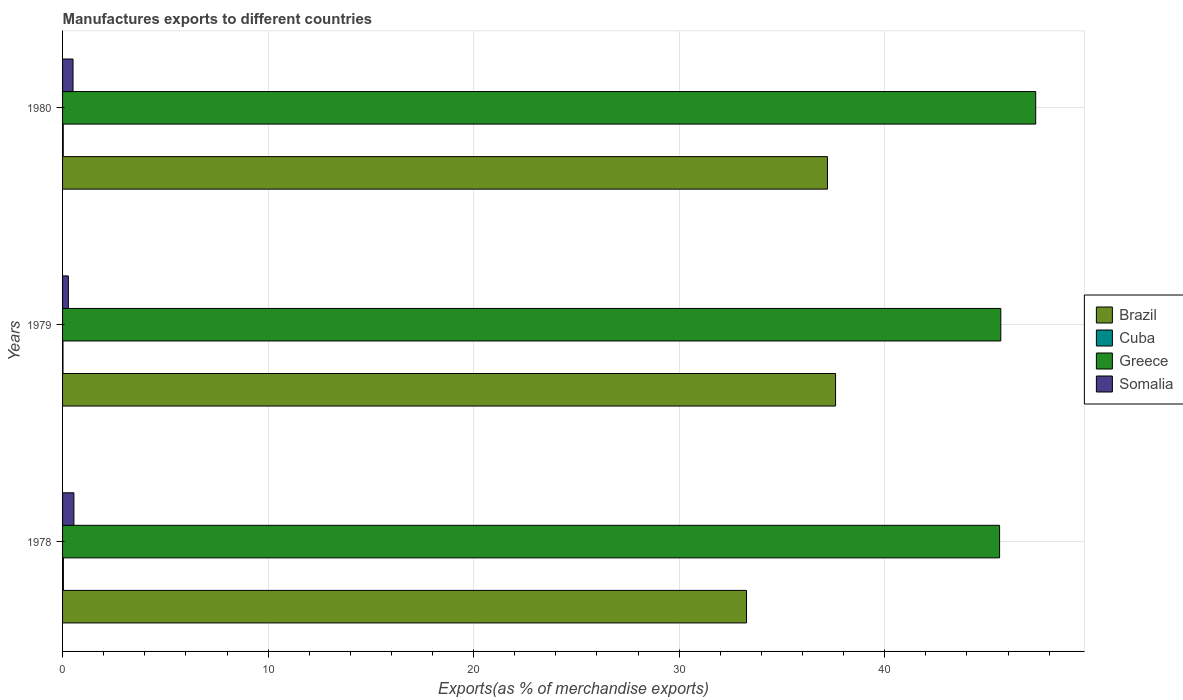How many different coloured bars are there?
Your answer should be compact. 4. Are the number of bars per tick equal to the number of legend labels?
Make the answer very short. Yes. How many bars are there on the 2nd tick from the top?
Offer a very short reply. 4. What is the label of the 1st group of bars from the top?
Give a very brief answer. 1980. In how many cases, is the number of bars for a given year not equal to the number of legend labels?
Keep it short and to the point. 0. What is the percentage of exports to different countries in Somalia in 1979?
Give a very brief answer. 0.28. Across all years, what is the maximum percentage of exports to different countries in Greece?
Provide a succinct answer. 47.35. Across all years, what is the minimum percentage of exports to different countries in Somalia?
Give a very brief answer. 0.28. In which year was the percentage of exports to different countries in Brazil maximum?
Provide a succinct answer. 1979. In which year was the percentage of exports to different countries in Cuba minimum?
Make the answer very short. 1979. What is the total percentage of exports to different countries in Cuba in the graph?
Give a very brief answer. 0.09. What is the difference between the percentage of exports to different countries in Somalia in 1979 and that in 1980?
Your answer should be compact. -0.23. What is the difference between the percentage of exports to different countries in Greece in 1980 and the percentage of exports to different countries in Brazil in 1978?
Your answer should be compact. 14.07. What is the average percentage of exports to different countries in Somalia per year?
Make the answer very short. 0.45. In the year 1978, what is the difference between the percentage of exports to different countries in Somalia and percentage of exports to different countries in Greece?
Make the answer very short. -45.04. In how many years, is the percentage of exports to different countries in Somalia greater than 12 %?
Make the answer very short. 0. What is the ratio of the percentage of exports to different countries in Somalia in 1979 to that in 1980?
Your answer should be compact. 0.56. Is the percentage of exports to different countries in Brazil in 1979 less than that in 1980?
Offer a terse response. No. Is the difference between the percentage of exports to different countries in Somalia in 1979 and 1980 greater than the difference between the percentage of exports to different countries in Greece in 1979 and 1980?
Give a very brief answer. Yes. What is the difference between the highest and the second highest percentage of exports to different countries in Brazil?
Make the answer very short. 0.4. What is the difference between the highest and the lowest percentage of exports to different countries in Greece?
Provide a short and direct response. 1.76. In how many years, is the percentage of exports to different countries in Brazil greater than the average percentage of exports to different countries in Brazil taken over all years?
Provide a succinct answer. 2. Is it the case that in every year, the sum of the percentage of exports to different countries in Somalia and percentage of exports to different countries in Cuba is greater than the sum of percentage of exports to different countries in Brazil and percentage of exports to different countries in Greece?
Give a very brief answer. No. What does the 1st bar from the top in 1978 represents?
Your answer should be very brief. Somalia. What does the 1st bar from the bottom in 1978 represents?
Your answer should be very brief. Brazil. How many bars are there?
Offer a very short reply. 12. What is the difference between two consecutive major ticks on the X-axis?
Ensure brevity in your answer.  10. Does the graph contain any zero values?
Ensure brevity in your answer.  No. Does the graph contain grids?
Provide a succinct answer. Yes. Where does the legend appear in the graph?
Your answer should be compact. Center right. How many legend labels are there?
Keep it short and to the point. 4. How are the legend labels stacked?
Your response must be concise. Vertical. What is the title of the graph?
Offer a very short reply. Manufactures exports to different countries. Does "Kenya" appear as one of the legend labels in the graph?
Keep it short and to the point. No. What is the label or title of the X-axis?
Your answer should be very brief. Exports(as % of merchandise exports). What is the label or title of the Y-axis?
Your response must be concise. Years. What is the Exports(as % of merchandise exports) of Brazil in 1978?
Make the answer very short. 33.28. What is the Exports(as % of merchandise exports) in Cuba in 1978?
Ensure brevity in your answer.  0.04. What is the Exports(as % of merchandise exports) in Greece in 1978?
Your response must be concise. 45.59. What is the Exports(as % of merchandise exports) in Somalia in 1978?
Your answer should be very brief. 0.55. What is the Exports(as % of merchandise exports) of Brazil in 1979?
Give a very brief answer. 37.61. What is the Exports(as % of merchandise exports) of Cuba in 1979?
Keep it short and to the point. 0.02. What is the Exports(as % of merchandise exports) of Greece in 1979?
Keep it short and to the point. 45.65. What is the Exports(as % of merchandise exports) of Somalia in 1979?
Give a very brief answer. 0.28. What is the Exports(as % of merchandise exports) of Brazil in 1980?
Give a very brief answer. 37.21. What is the Exports(as % of merchandise exports) of Cuba in 1980?
Provide a succinct answer. 0.03. What is the Exports(as % of merchandise exports) in Greece in 1980?
Make the answer very short. 47.35. What is the Exports(as % of merchandise exports) of Somalia in 1980?
Offer a very short reply. 0.51. Across all years, what is the maximum Exports(as % of merchandise exports) in Brazil?
Provide a short and direct response. 37.61. Across all years, what is the maximum Exports(as % of merchandise exports) in Cuba?
Your response must be concise. 0.04. Across all years, what is the maximum Exports(as % of merchandise exports) of Greece?
Provide a short and direct response. 47.35. Across all years, what is the maximum Exports(as % of merchandise exports) of Somalia?
Make the answer very short. 0.55. Across all years, what is the minimum Exports(as % of merchandise exports) in Brazil?
Your answer should be compact. 33.28. Across all years, what is the minimum Exports(as % of merchandise exports) of Cuba?
Provide a succinct answer. 0.02. Across all years, what is the minimum Exports(as % of merchandise exports) of Greece?
Give a very brief answer. 45.59. Across all years, what is the minimum Exports(as % of merchandise exports) in Somalia?
Your answer should be very brief. 0.28. What is the total Exports(as % of merchandise exports) of Brazil in the graph?
Keep it short and to the point. 108.1. What is the total Exports(as % of merchandise exports) of Cuba in the graph?
Your answer should be very brief. 0.09. What is the total Exports(as % of merchandise exports) in Greece in the graph?
Make the answer very short. 138.58. What is the total Exports(as % of merchandise exports) in Somalia in the graph?
Make the answer very short. 1.34. What is the difference between the Exports(as % of merchandise exports) in Brazil in 1978 and that in 1979?
Your answer should be compact. -4.33. What is the difference between the Exports(as % of merchandise exports) of Cuba in 1978 and that in 1979?
Ensure brevity in your answer.  0.02. What is the difference between the Exports(as % of merchandise exports) in Greece in 1978 and that in 1979?
Your answer should be compact. -0.06. What is the difference between the Exports(as % of merchandise exports) of Somalia in 1978 and that in 1979?
Your response must be concise. 0.27. What is the difference between the Exports(as % of merchandise exports) of Brazil in 1978 and that in 1980?
Your response must be concise. -3.94. What is the difference between the Exports(as % of merchandise exports) of Cuba in 1978 and that in 1980?
Make the answer very short. 0.01. What is the difference between the Exports(as % of merchandise exports) in Greece in 1978 and that in 1980?
Provide a short and direct response. -1.76. What is the difference between the Exports(as % of merchandise exports) in Somalia in 1978 and that in 1980?
Give a very brief answer. 0.04. What is the difference between the Exports(as % of merchandise exports) of Brazil in 1979 and that in 1980?
Keep it short and to the point. 0.4. What is the difference between the Exports(as % of merchandise exports) in Cuba in 1979 and that in 1980?
Give a very brief answer. -0.01. What is the difference between the Exports(as % of merchandise exports) in Greece in 1979 and that in 1980?
Offer a terse response. -1.7. What is the difference between the Exports(as % of merchandise exports) in Somalia in 1979 and that in 1980?
Provide a succinct answer. -0.23. What is the difference between the Exports(as % of merchandise exports) in Brazil in 1978 and the Exports(as % of merchandise exports) in Cuba in 1979?
Offer a very short reply. 33.26. What is the difference between the Exports(as % of merchandise exports) in Brazil in 1978 and the Exports(as % of merchandise exports) in Greece in 1979?
Ensure brevity in your answer.  -12.37. What is the difference between the Exports(as % of merchandise exports) in Brazil in 1978 and the Exports(as % of merchandise exports) in Somalia in 1979?
Offer a terse response. 32.99. What is the difference between the Exports(as % of merchandise exports) of Cuba in 1978 and the Exports(as % of merchandise exports) of Greece in 1979?
Provide a succinct answer. -45.61. What is the difference between the Exports(as % of merchandise exports) in Cuba in 1978 and the Exports(as % of merchandise exports) in Somalia in 1979?
Keep it short and to the point. -0.24. What is the difference between the Exports(as % of merchandise exports) of Greece in 1978 and the Exports(as % of merchandise exports) of Somalia in 1979?
Make the answer very short. 45.31. What is the difference between the Exports(as % of merchandise exports) in Brazil in 1978 and the Exports(as % of merchandise exports) in Cuba in 1980?
Keep it short and to the point. 33.24. What is the difference between the Exports(as % of merchandise exports) in Brazil in 1978 and the Exports(as % of merchandise exports) in Greece in 1980?
Your answer should be very brief. -14.07. What is the difference between the Exports(as % of merchandise exports) in Brazil in 1978 and the Exports(as % of merchandise exports) in Somalia in 1980?
Your response must be concise. 32.77. What is the difference between the Exports(as % of merchandise exports) of Cuba in 1978 and the Exports(as % of merchandise exports) of Greece in 1980?
Offer a very short reply. -47.31. What is the difference between the Exports(as % of merchandise exports) in Cuba in 1978 and the Exports(as % of merchandise exports) in Somalia in 1980?
Keep it short and to the point. -0.47. What is the difference between the Exports(as % of merchandise exports) in Greece in 1978 and the Exports(as % of merchandise exports) in Somalia in 1980?
Your answer should be compact. 45.08. What is the difference between the Exports(as % of merchandise exports) in Brazil in 1979 and the Exports(as % of merchandise exports) in Cuba in 1980?
Provide a succinct answer. 37.58. What is the difference between the Exports(as % of merchandise exports) in Brazil in 1979 and the Exports(as % of merchandise exports) in Greece in 1980?
Keep it short and to the point. -9.74. What is the difference between the Exports(as % of merchandise exports) of Brazil in 1979 and the Exports(as % of merchandise exports) of Somalia in 1980?
Make the answer very short. 37.1. What is the difference between the Exports(as % of merchandise exports) of Cuba in 1979 and the Exports(as % of merchandise exports) of Greece in 1980?
Give a very brief answer. -47.33. What is the difference between the Exports(as % of merchandise exports) in Cuba in 1979 and the Exports(as % of merchandise exports) in Somalia in 1980?
Your response must be concise. -0.49. What is the difference between the Exports(as % of merchandise exports) of Greece in 1979 and the Exports(as % of merchandise exports) of Somalia in 1980?
Make the answer very short. 45.14. What is the average Exports(as % of merchandise exports) in Brazil per year?
Your response must be concise. 36.03. What is the average Exports(as % of merchandise exports) of Cuba per year?
Your answer should be very brief. 0.03. What is the average Exports(as % of merchandise exports) in Greece per year?
Keep it short and to the point. 46.19. What is the average Exports(as % of merchandise exports) of Somalia per year?
Give a very brief answer. 0.45. In the year 1978, what is the difference between the Exports(as % of merchandise exports) of Brazil and Exports(as % of merchandise exports) of Cuba?
Your answer should be compact. 33.24. In the year 1978, what is the difference between the Exports(as % of merchandise exports) of Brazil and Exports(as % of merchandise exports) of Greece?
Provide a short and direct response. -12.31. In the year 1978, what is the difference between the Exports(as % of merchandise exports) in Brazil and Exports(as % of merchandise exports) in Somalia?
Your response must be concise. 32.72. In the year 1978, what is the difference between the Exports(as % of merchandise exports) in Cuba and Exports(as % of merchandise exports) in Greece?
Your answer should be compact. -45.55. In the year 1978, what is the difference between the Exports(as % of merchandise exports) of Cuba and Exports(as % of merchandise exports) of Somalia?
Make the answer very short. -0.51. In the year 1978, what is the difference between the Exports(as % of merchandise exports) of Greece and Exports(as % of merchandise exports) of Somalia?
Ensure brevity in your answer.  45.04. In the year 1979, what is the difference between the Exports(as % of merchandise exports) in Brazil and Exports(as % of merchandise exports) in Cuba?
Offer a very short reply. 37.59. In the year 1979, what is the difference between the Exports(as % of merchandise exports) in Brazil and Exports(as % of merchandise exports) in Greece?
Offer a terse response. -8.04. In the year 1979, what is the difference between the Exports(as % of merchandise exports) in Brazil and Exports(as % of merchandise exports) in Somalia?
Your answer should be very brief. 37.33. In the year 1979, what is the difference between the Exports(as % of merchandise exports) of Cuba and Exports(as % of merchandise exports) of Greece?
Offer a very short reply. -45.63. In the year 1979, what is the difference between the Exports(as % of merchandise exports) in Cuba and Exports(as % of merchandise exports) in Somalia?
Offer a very short reply. -0.26. In the year 1979, what is the difference between the Exports(as % of merchandise exports) in Greece and Exports(as % of merchandise exports) in Somalia?
Provide a succinct answer. 45.36. In the year 1980, what is the difference between the Exports(as % of merchandise exports) of Brazil and Exports(as % of merchandise exports) of Cuba?
Provide a short and direct response. 37.18. In the year 1980, what is the difference between the Exports(as % of merchandise exports) of Brazil and Exports(as % of merchandise exports) of Greece?
Your answer should be very brief. -10.13. In the year 1980, what is the difference between the Exports(as % of merchandise exports) in Brazil and Exports(as % of merchandise exports) in Somalia?
Keep it short and to the point. 36.71. In the year 1980, what is the difference between the Exports(as % of merchandise exports) in Cuba and Exports(as % of merchandise exports) in Greece?
Your answer should be compact. -47.31. In the year 1980, what is the difference between the Exports(as % of merchandise exports) in Cuba and Exports(as % of merchandise exports) in Somalia?
Your answer should be compact. -0.48. In the year 1980, what is the difference between the Exports(as % of merchandise exports) of Greece and Exports(as % of merchandise exports) of Somalia?
Your answer should be very brief. 46.84. What is the ratio of the Exports(as % of merchandise exports) in Brazil in 1978 to that in 1979?
Make the answer very short. 0.88. What is the ratio of the Exports(as % of merchandise exports) of Cuba in 1978 to that in 1979?
Offer a terse response. 1.98. What is the ratio of the Exports(as % of merchandise exports) in Somalia in 1978 to that in 1979?
Keep it short and to the point. 1.95. What is the ratio of the Exports(as % of merchandise exports) in Brazil in 1978 to that in 1980?
Ensure brevity in your answer.  0.89. What is the ratio of the Exports(as % of merchandise exports) in Cuba in 1978 to that in 1980?
Offer a terse response. 1.22. What is the ratio of the Exports(as % of merchandise exports) in Greece in 1978 to that in 1980?
Give a very brief answer. 0.96. What is the ratio of the Exports(as % of merchandise exports) in Somalia in 1978 to that in 1980?
Offer a terse response. 1.09. What is the ratio of the Exports(as % of merchandise exports) in Brazil in 1979 to that in 1980?
Provide a short and direct response. 1.01. What is the ratio of the Exports(as % of merchandise exports) in Cuba in 1979 to that in 1980?
Your response must be concise. 0.61. What is the ratio of the Exports(as % of merchandise exports) in Greece in 1979 to that in 1980?
Make the answer very short. 0.96. What is the ratio of the Exports(as % of merchandise exports) in Somalia in 1979 to that in 1980?
Keep it short and to the point. 0.56. What is the difference between the highest and the second highest Exports(as % of merchandise exports) in Brazil?
Give a very brief answer. 0.4. What is the difference between the highest and the second highest Exports(as % of merchandise exports) of Cuba?
Ensure brevity in your answer.  0.01. What is the difference between the highest and the second highest Exports(as % of merchandise exports) of Greece?
Ensure brevity in your answer.  1.7. What is the difference between the highest and the second highest Exports(as % of merchandise exports) of Somalia?
Provide a short and direct response. 0.04. What is the difference between the highest and the lowest Exports(as % of merchandise exports) in Brazil?
Your answer should be very brief. 4.33. What is the difference between the highest and the lowest Exports(as % of merchandise exports) in Cuba?
Offer a very short reply. 0.02. What is the difference between the highest and the lowest Exports(as % of merchandise exports) in Greece?
Your response must be concise. 1.76. What is the difference between the highest and the lowest Exports(as % of merchandise exports) in Somalia?
Provide a succinct answer. 0.27. 